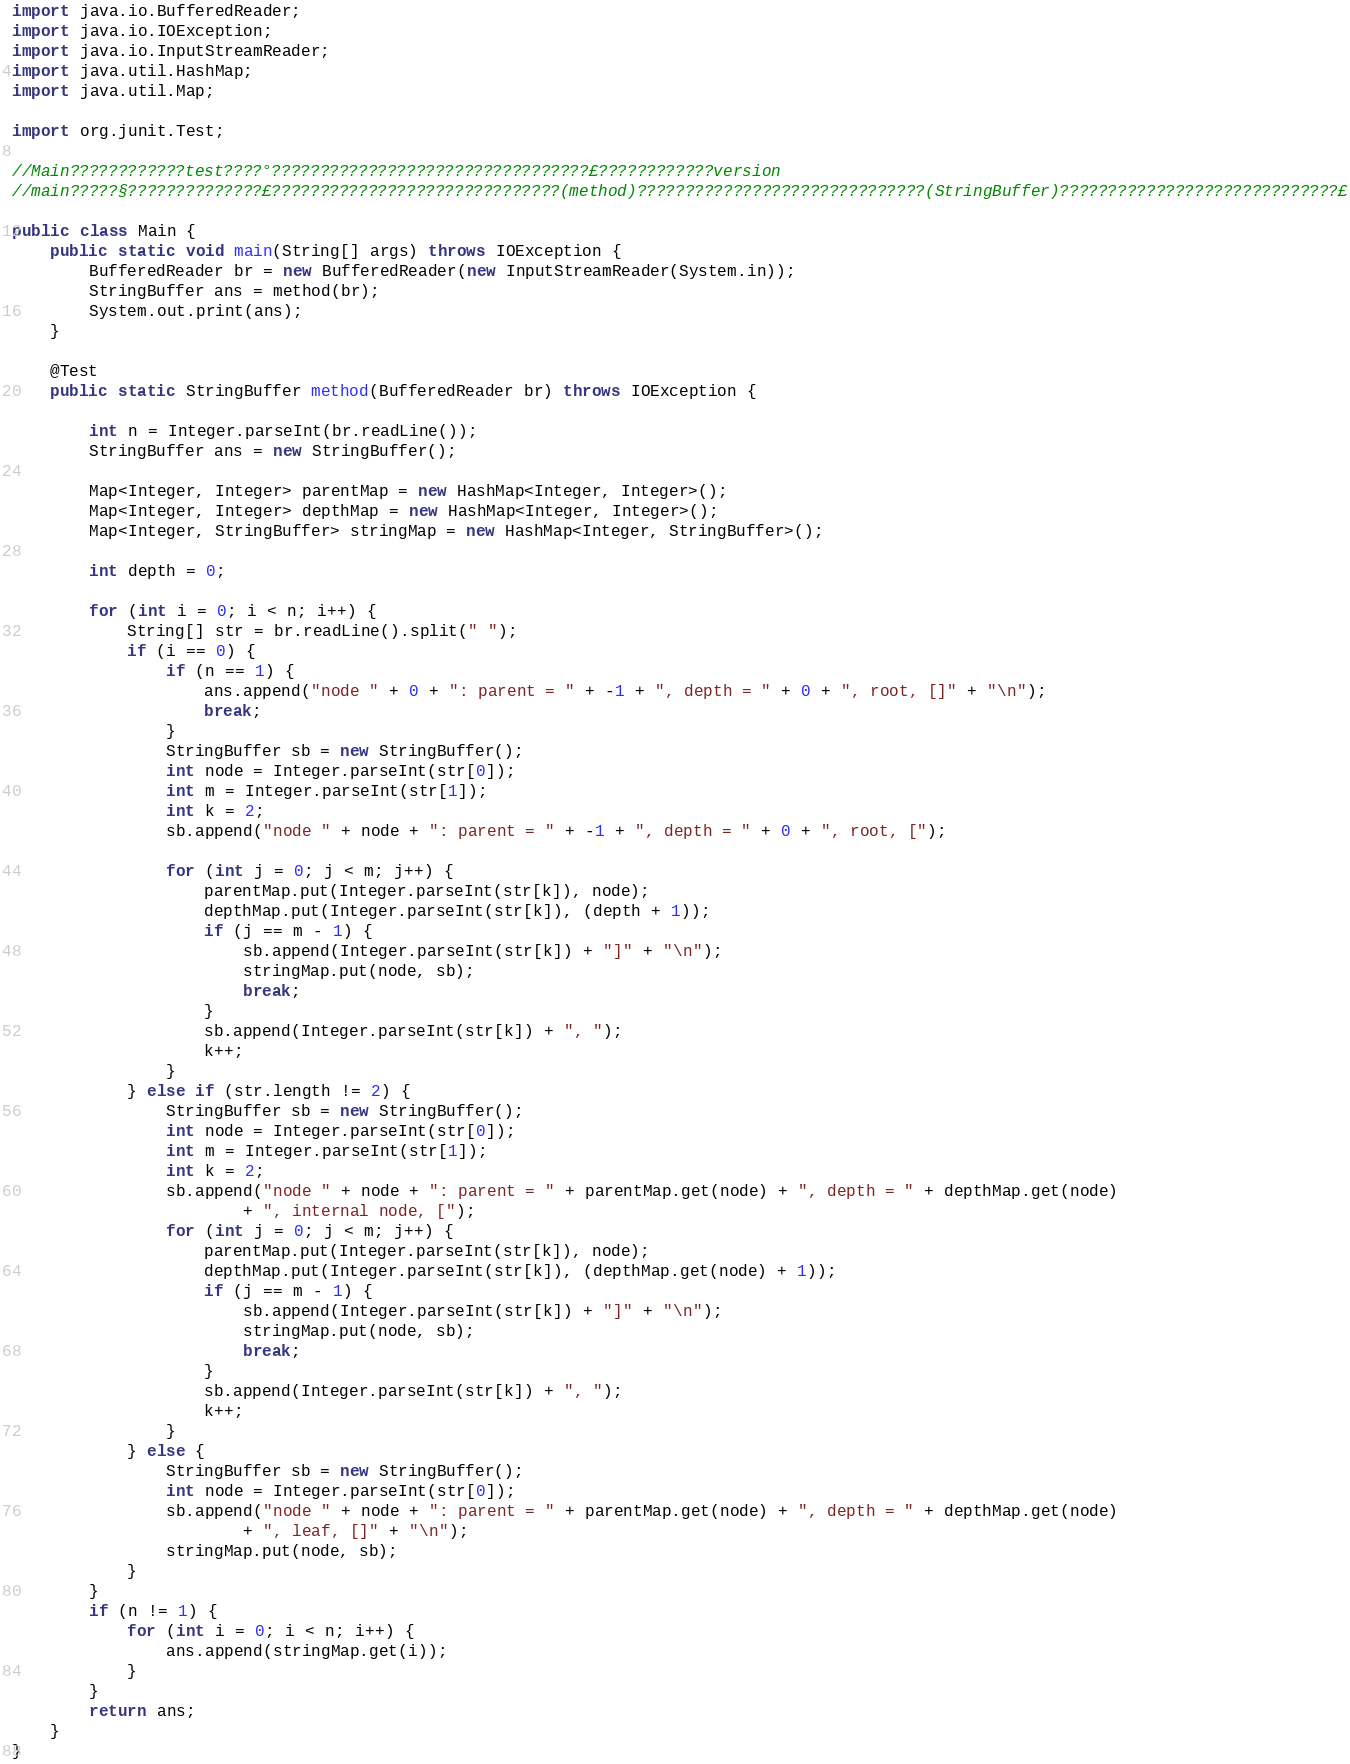Convert code to text. <code><loc_0><loc_0><loc_500><loc_500><_Java_>import java.io.BufferedReader;
import java.io.IOException;
import java.io.InputStreamReader;
import java.util.HashMap;
import java.util.Map;

import org.junit.Test;

//Main????????????test????°?????????????????????????????????£????????????version
//main?????§??????????????£??????????????????????????????(method)??????????????????????????????(StringBuffer)?????????????????????????????£

public class Main {
	public static void main(String[] args) throws IOException {
		BufferedReader br = new BufferedReader(new InputStreamReader(System.in));
		StringBuffer ans = method(br);
		System.out.print(ans);
	}

	@Test
	public static StringBuffer method(BufferedReader br) throws IOException {

		int n = Integer.parseInt(br.readLine());
		StringBuffer ans = new StringBuffer();

		Map<Integer, Integer> parentMap = new HashMap<Integer, Integer>();
		Map<Integer, Integer> depthMap = new HashMap<Integer, Integer>();
		Map<Integer, StringBuffer> stringMap = new HashMap<Integer, StringBuffer>();

		int depth = 0;

		for (int i = 0; i < n; i++) {
			String[] str = br.readLine().split(" ");
			if (i == 0) {
				if (n == 1) {
					ans.append("node " + 0 + ": parent = " + -1 + ", depth = " + 0 + ", root, []" + "\n");
					break;
				}
				StringBuffer sb = new StringBuffer();
				int node = Integer.parseInt(str[0]);
				int m = Integer.parseInt(str[1]);
				int k = 2;
				sb.append("node " + node + ": parent = " + -1 + ", depth = " + 0 + ", root, [");

				for (int j = 0; j < m; j++) {
					parentMap.put(Integer.parseInt(str[k]), node);
					depthMap.put(Integer.parseInt(str[k]), (depth + 1));
					if (j == m - 1) {
						sb.append(Integer.parseInt(str[k]) + "]" + "\n");
						stringMap.put(node, sb);
						break;
					}
					sb.append(Integer.parseInt(str[k]) + ", ");
					k++;
				}
			} else if (str.length != 2) {
				StringBuffer sb = new StringBuffer();
				int node = Integer.parseInt(str[0]);
				int m = Integer.parseInt(str[1]);
				int k = 2;
				sb.append("node " + node + ": parent = " + parentMap.get(node) + ", depth = " + depthMap.get(node)
						+ ", internal node, [");
				for (int j = 0; j < m; j++) {
					parentMap.put(Integer.parseInt(str[k]), node);
					depthMap.put(Integer.parseInt(str[k]), (depthMap.get(node) + 1));
					if (j == m - 1) {
						sb.append(Integer.parseInt(str[k]) + "]" + "\n");
						stringMap.put(node, sb);
						break;
					}
					sb.append(Integer.parseInt(str[k]) + ", ");
					k++;
				}
			} else {
				StringBuffer sb = new StringBuffer();
				int node = Integer.parseInt(str[0]);
				sb.append("node " + node + ": parent = " + parentMap.get(node) + ", depth = " + depthMap.get(node)
						+ ", leaf, []" + "\n");
				stringMap.put(node, sb);
			}
		}
		if (n != 1) {
			for (int i = 0; i < n; i++) {
				ans.append(stringMap.get(i));
			}
		}
		return ans;
	}
}</code> 